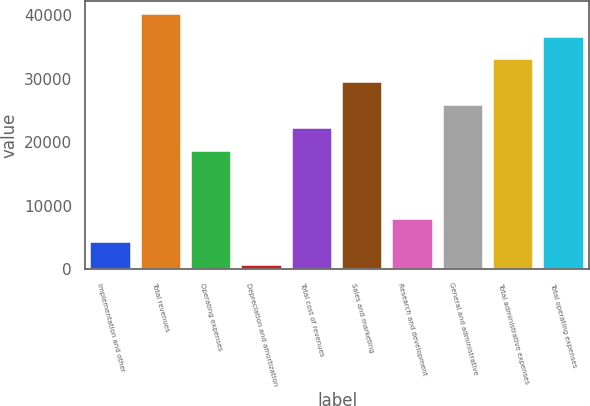Convert chart. <chart><loc_0><loc_0><loc_500><loc_500><bar_chart><fcel>Implementation and other<fcel>Total revenues<fcel>Operating expenses<fcel>Depreciation and amortization<fcel>Total cost of revenues<fcel>Sales and marketing<fcel>Research and development<fcel>General and administrative<fcel>Total administrative expenses<fcel>Total operating expenses<nl><fcel>4234<fcel>40194<fcel>18618<fcel>638<fcel>22214<fcel>29406<fcel>7830<fcel>25810<fcel>33002<fcel>36598<nl></chart> 